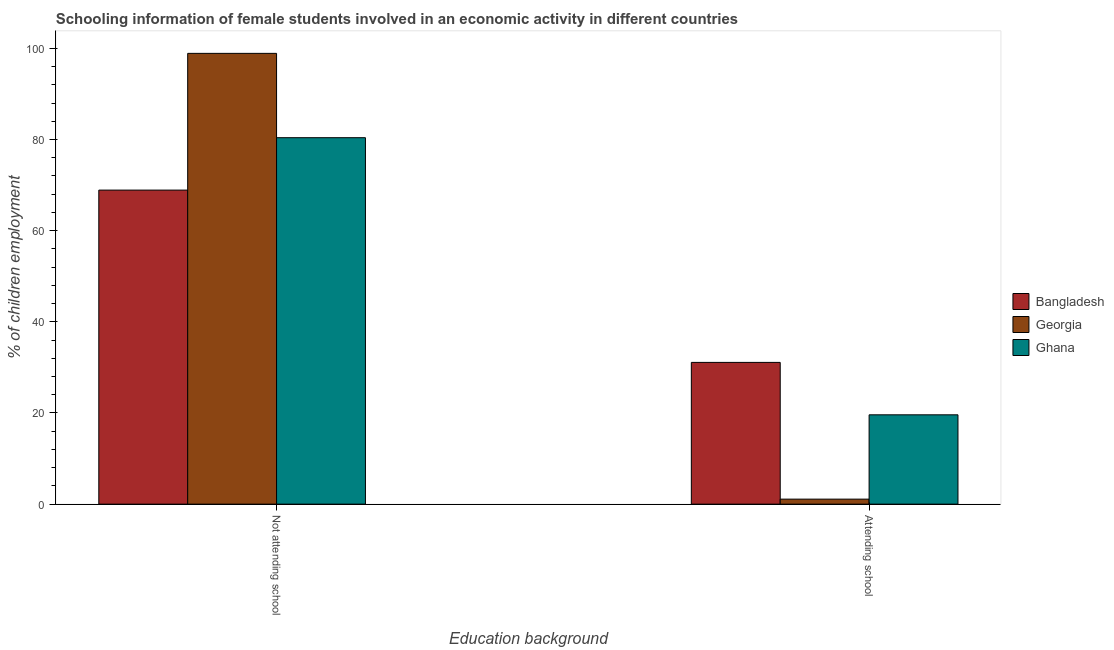How many bars are there on the 1st tick from the right?
Provide a succinct answer. 3. What is the label of the 2nd group of bars from the left?
Give a very brief answer. Attending school. What is the percentage of employed females who are attending school in Georgia?
Provide a short and direct response. 1.1. Across all countries, what is the maximum percentage of employed females who are not attending school?
Provide a succinct answer. 98.9. Across all countries, what is the minimum percentage of employed females who are not attending school?
Keep it short and to the point. 68.9. In which country was the percentage of employed females who are not attending school maximum?
Your answer should be compact. Georgia. In which country was the percentage of employed females who are not attending school minimum?
Provide a short and direct response. Bangladesh. What is the total percentage of employed females who are attending school in the graph?
Keep it short and to the point. 51.8. What is the difference between the percentage of employed females who are attending school in Ghana and that in Bangladesh?
Your answer should be very brief. -11.5. What is the difference between the percentage of employed females who are not attending school in Ghana and the percentage of employed females who are attending school in Georgia?
Offer a very short reply. 79.3. What is the average percentage of employed females who are not attending school per country?
Give a very brief answer. 82.73. What is the difference between the percentage of employed females who are not attending school and percentage of employed females who are attending school in Ghana?
Your answer should be very brief. 60.8. In how many countries, is the percentage of employed females who are not attending school greater than 28 %?
Offer a very short reply. 3. What is the ratio of the percentage of employed females who are attending school in Ghana to that in Bangladesh?
Your answer should be very brief. 0.63. Is the percentage of employed females who are attending school in Bangladesh less than that in Ghana?
Your answer should be very brief. No. What does the 2nd bar from the left in Not attending school represents?
Keep it short and to the point. Georgia. What does the 2nd bar from the right in Attending school represents?
Offer a terse response. Georgia. Are all the bars in the graph horizontal?
Keep it short and to the point. No. What is the difference between two consecutive major ticks on the Y-axis?
Your answer should be compact. 20. Are the values on the major ticks of Y-axis written in scientific E-notation?
Keep it short and to the point. No. Does the graph contain grids?
Provide a succinct answer. No. Where does the legend appear in the graph?
Your answer should be very brief. Center right. How are the legend labels stacked?
Your answer should be very brief. Vertical. What is the title of the graph?
Your answer should be compact. Schooling information of female students involved in an economic activity in different countries. Does "Afghanistan" appear as one of the legend labels in the graph?
Make the answer very short. No. What is the label or title of the X-axis?
Ensure brevity in your answer.  Education background. What is the label or title of the Y-axis?
Offer a very short reply. % of children employment. What is the % of children employment of Bangladesh in Not attending school?
Provide a short and direct response. 68.9. What is the % of children employment in Georgia in Not attending school?
Provide a short and direct response. 98.9. What is the % of children employment in Ghana in Not attending school?
Ensure brevity in your answer.  80.4. What is the % of children employment in Bangladesh in Attending school?
Provide a succinct answer. 31.1. What is the % of children employment in Ghana in Attending school?
Offer a terse response. 19.6. Across all Education background, what is the maximum % of children employment of Bangladesh?
Your answer should be compact. 68.9. Across all Education background, what is the maximum % of children employment of Georgia?
Keep it short and to the point. 98.9. Across all Education background, what is the maximum % of children employment in Ghana?
Your answer should be very brief. 80.4. Across all Education background, what is the minimum % of children employment in Bangladesh?
Your response must be concise. 31.1. Across all Education background, what is the minimum % of children employment in Ghana?
Provide a succinct answer. 19.6. What is the difference between the % of children employment of Bangladesh in Not attending school and that in Attending school?
Your response must be concise. 37.8. What is the difference between the % of children employment in Georgia in Not attending school and that in Attending school?
Offer a very short reply. 97.8. What is the difference between the % of children employment in Ghana in Not attending school and that in Attending school?
Your response must be concise. 60.8. What is the difference between the % of children employment in Bangladesh in Not attending school and the % of children employment in Georgia in Attending school?
Provide a succinct answer. 67.8. What is the difference between the % of children employment of Bangladesh in Not attending school and the % of children employment of Ghana in Attending school?
Keep it short and to the point. 49.3. What is the difference between the % of children employment in Georgia in Not attending school and the % of children employment in Ghana in Attending school?
Make the answer very short. 79.3. What is the difference between the % of children employment of Bangladesh and % of children employment of Ghana in Not attending school?
Provide a short and direct response. -11.5. What is the difference between the % of children employment of Bangladesh and % of children employment of Georgia in Attending school?
Your answer should be compact. 30. What is the difference between the % of children employment in Bangladesh and % of children employment in Ghana in Attending school?
Provide a short and direct response. 11.5. What is the difference between the % of children employment in Georgia and % of children employment in Ghana in Attending school?
Make the answer very short. -18.5. What is the ratio of the % of children employment in Bangladesh in Not attending school to that in Attending school?
Your answer should be very brief. 2.22. What is the ratio of the % of children employment in Georgia in Not attending school to that in Attending school?
Provide a succinct answer. 89.91. What is the ratio of the % of children employment of Ghana in Not attending school to that in Attending school?
Provide a succinct answer. 4.1. What is the difference between the highest and the second highest % of children employment of Bangladesh?
Offer a terse response. 37.8. What is the difference between the highest and the second highest % of children employment of Georgia?
Provide a short and direct response. 97.8. What is the difference between the highest and the second highest % of children employment of Ghana?
Offer a very short reply. 60.8. What is the difference between the highest and the lowest % of children employment of Bangladesh?
Your response must be concise. 37.8. What is the difference between the highest and the lowest % of children employment of Georgia?
Provide a succinct answer. 97.8. What is the difference between the highest and the lowest % of children employment of Ghana?
Your response must be concise. 60.8. 